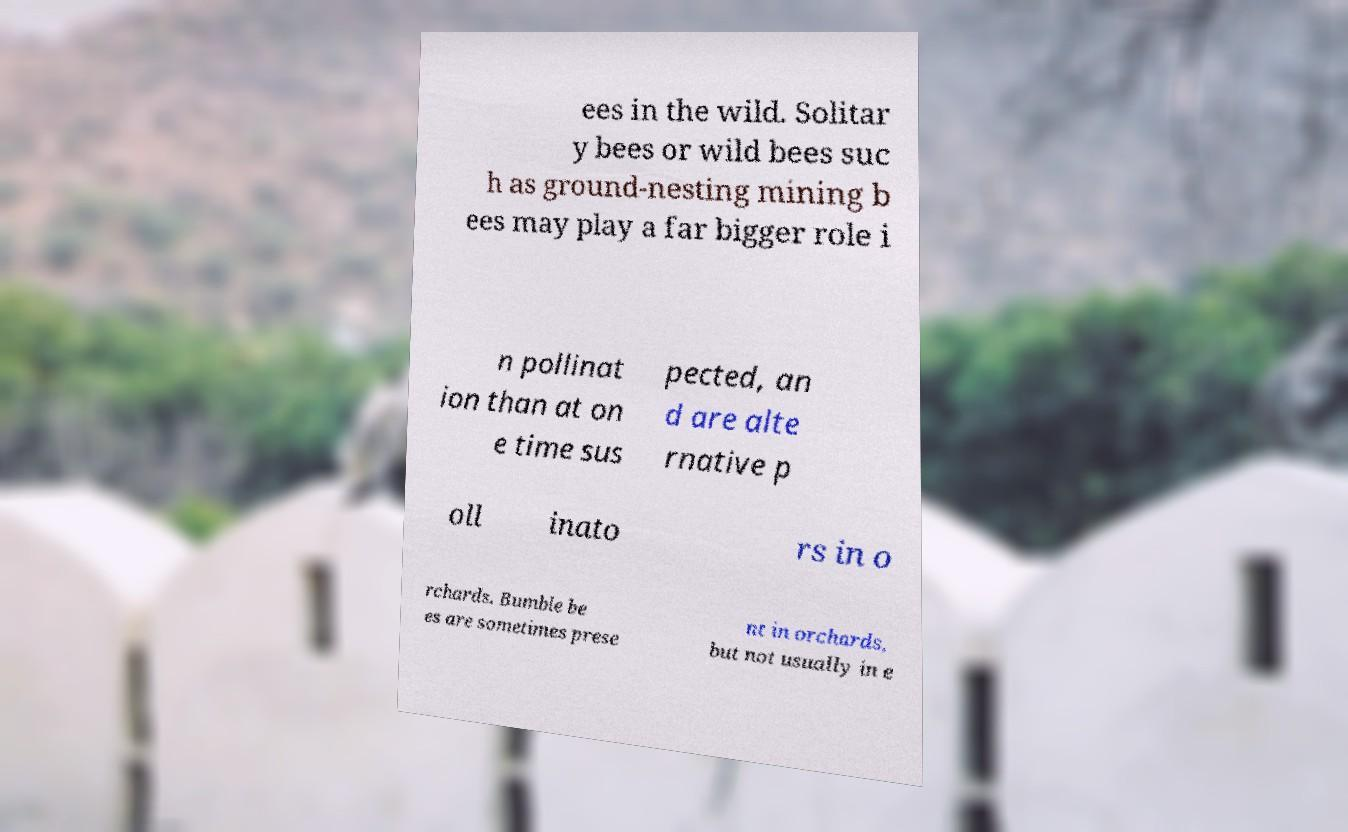Could you extract and type out the text from this image? ees in the wild. Solitar y bees or wild bees suc h as ground-nesting mining b ees may play a far bigger role i n pollinat ion than at on e time sus pected, an d are alte rnative p oll inato rs in o rchards. Bumble be es are sometimes prese nt in orchards, but not usually in e 